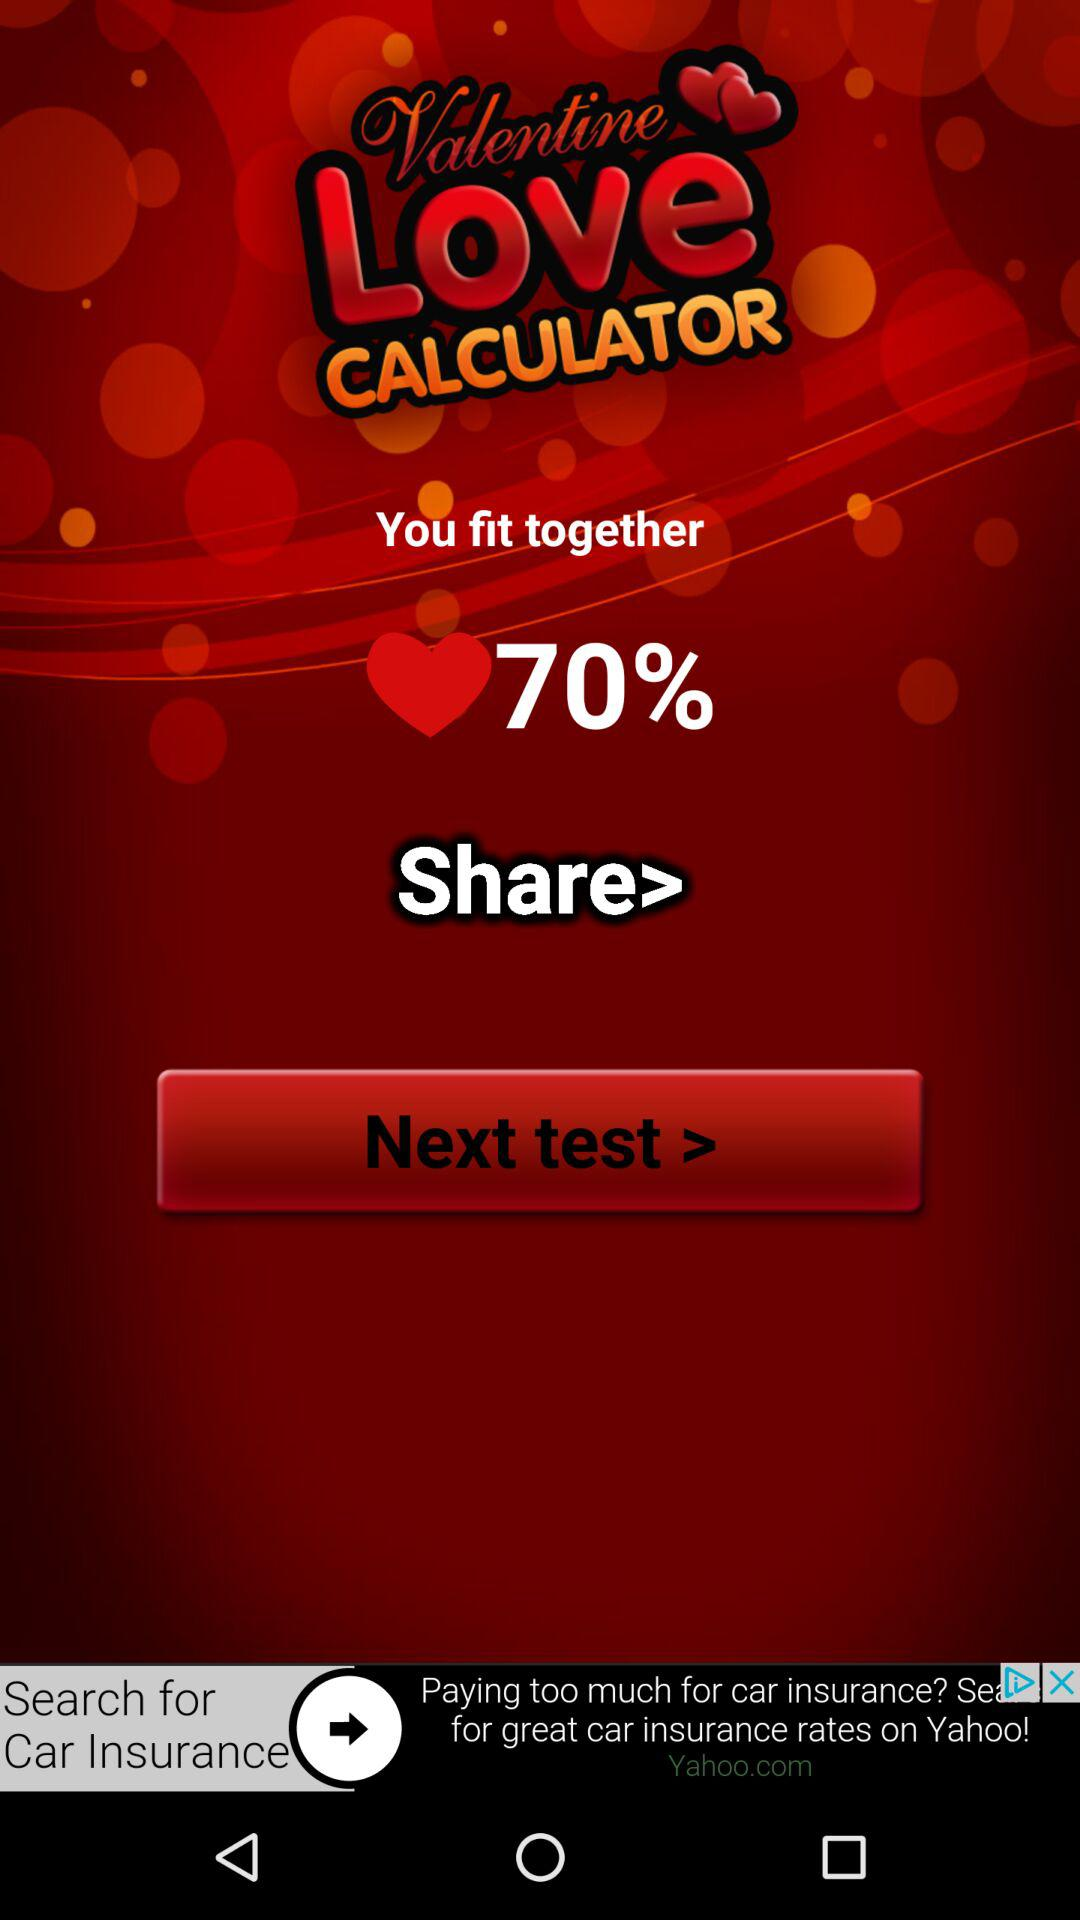What percentage do we fit together? We fit together 70%. 